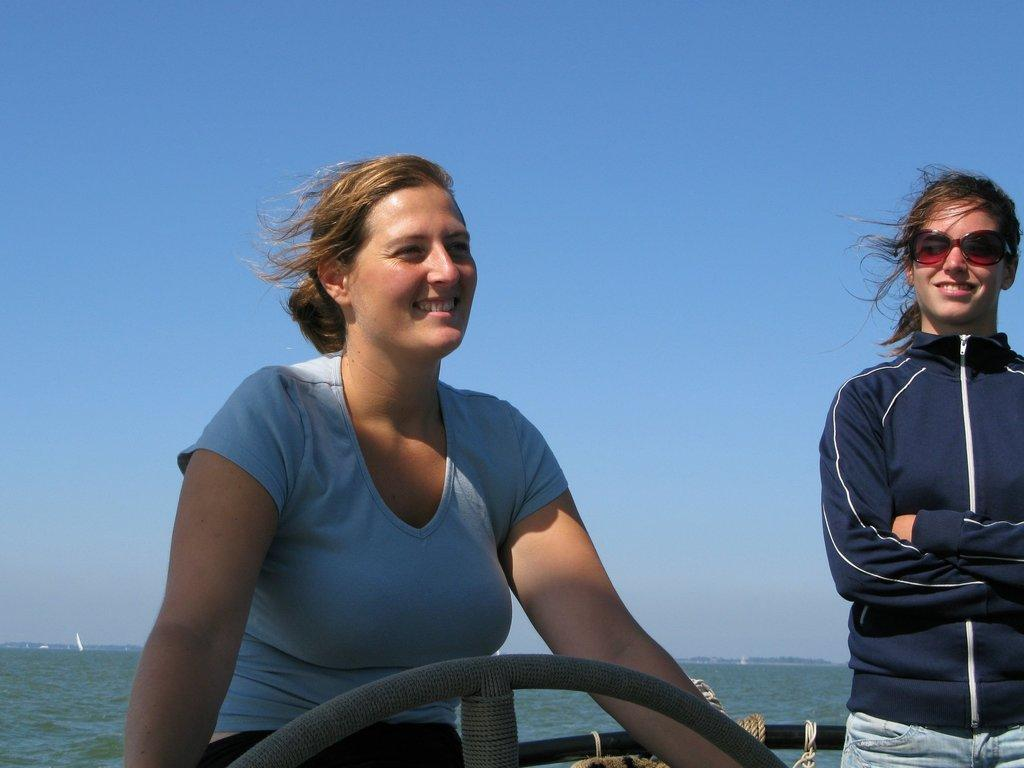How many people are in the image? There are two ladies in the image. What are the ladies doing in the image? The ladies are standing in a boat. What can be seen in the background of the image? There is water and the sky visible in the background of the image. What type of arch can be seen in the background of the image? There is no arch present in the background of the image. Can you describe the dog that is swimming next to the boat in the image? There is no dog present in the image; the ladies are standing in a boat with no other animals visible. 